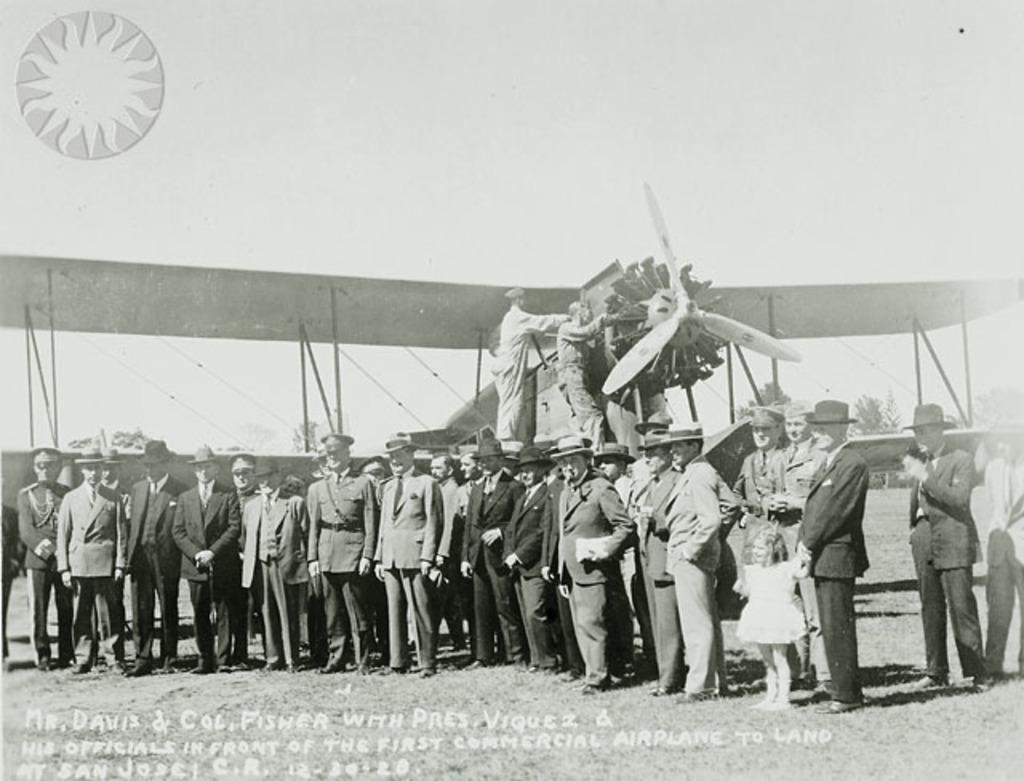Is this an airplane?
Your answer should be compact. Yes. Where was this picture taken?
Provide a succinct answer. San jose. 